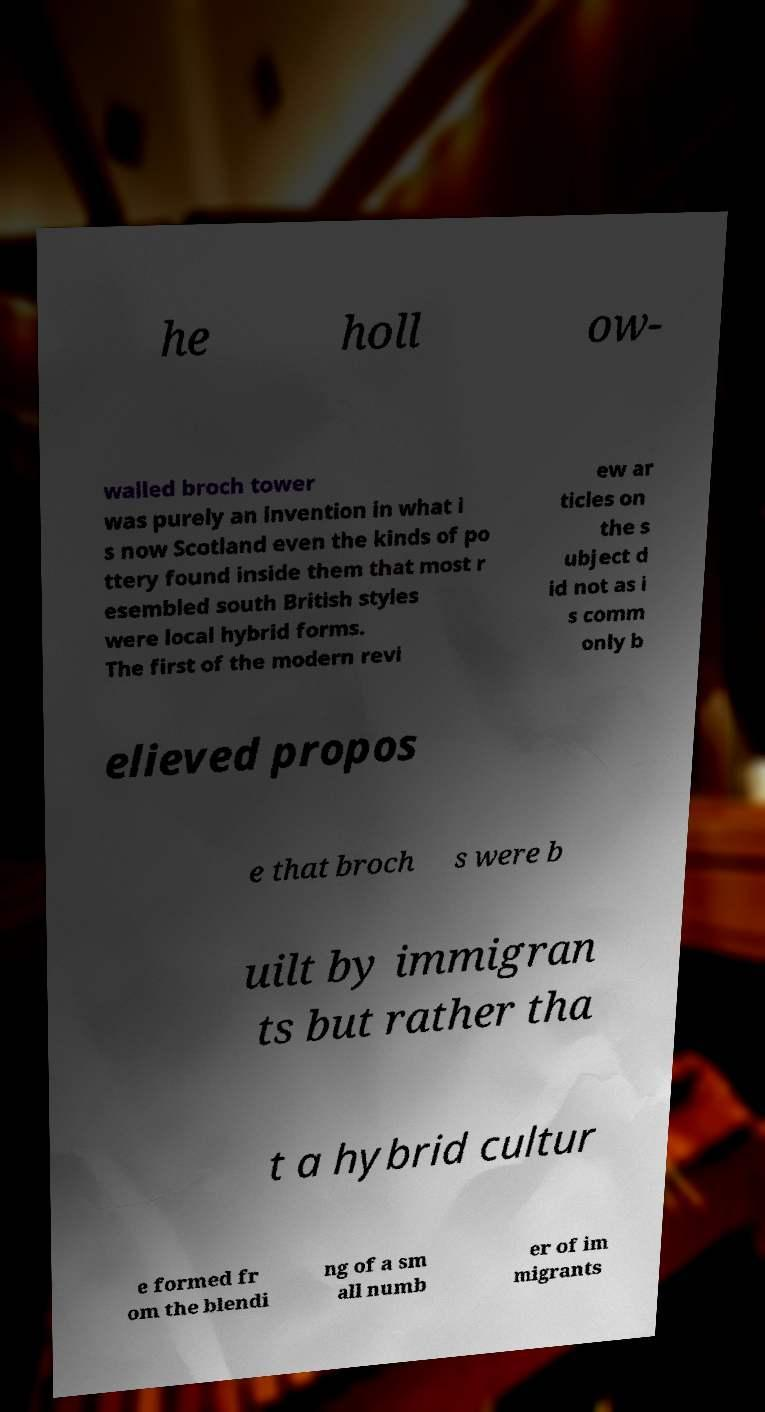Please identify and transcribe the text found in this image. he holl ow- walled broch tower was purely an invention in what i s now Scotland even the kinds of po ttery found inside them that most r esembled south British styles were local hybrid forms. The first of the modern revi ew ar ticles on the s ubject d id not as i s comm only b elieved propos e that broch s were b uilt by immigran ts but rather tha t a hybrid cultur e formed fr om the blendi ng of a sm all numb er of im migrants 